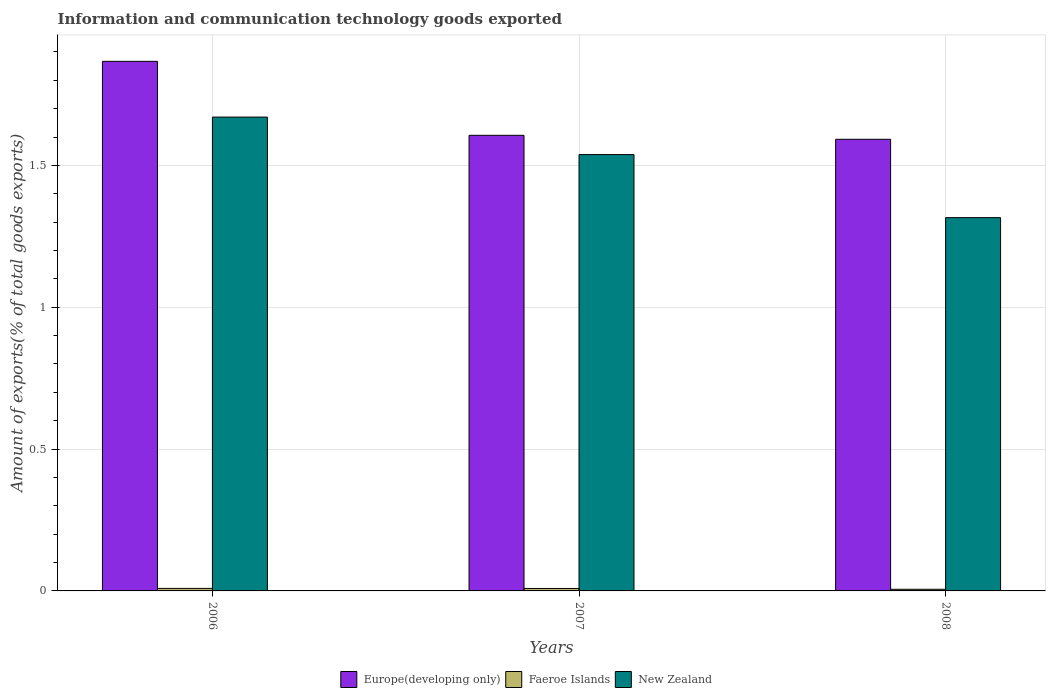How many groups of bars are there?
Your answer should be compact. 3. Are the number of bars per tick equal to the number of legend labels?
Offer a very short reply. Yes. How many bars are there on the 2nd tick from the right?
Give a very brief answer. 3. What is the label of the 2nd group of bars from the left?
Provide a short and direct response. 2007. In how many cases, is the number of bars for a given year not equal to the number of legend labels?
Give a very brief answer. 0. What is the amount of goods exported in Europe(developing only) in 2006?
Provide a short and direct response. 1.87. Across all years, what is the maximum amount of goods exported in New Zealand?
Offer a very short reply. 1.67. Across all years, what is the minimum amount of goods exported in Faeroe Islands?
Provide a succinct answer. 0.01. What is the total amount of goods exported in New Zealand in the graph?
Provide a succinct answer. 4.52. What is the difference between the amount of goods exported in Faeroe Islands in 2006 and that in 2008?
Ensure brevity in your answer.  0. What is the difference between the amount of goods exported in Europe(developing only) in 2007 and the amount of goods exported in New Zealand in 2006?
Offer a very short reply. -0.06. What is the average amount of goods exported in Europe(developing only) per year?
Your answer should be compact. 1.69. In the year 2007, what is the difference between the amount of goods exported in Europe(developing only) and amount of goods exported in Faeroe Islands?
Ensure brevity in your answer.  1.6. What is the ratio of the amount of goods exported in Faeroe Islands in 2006 to that in 2007?
Ensure brevity in your answer.  1.03. What is the difference between the highest and the second highest amount of goods exported in Faeroe Islands?
Make the answer very short. 0. What is the difference between the highest and the lowest amount of goods exported in Faeroe Islands?
Offer a terse response. 0. In how many years, is the amount of goods exported in New Zealand greater than the average amount of goods exported in New Zealand taken over all years?
Make the answer very short. 2. What does the 1st bar from the left in 2008 represents?
Make the answer very short. Europe(developing only). What does the 1st bar from the right in 2007 represents?
Keep it short and to the point. New Zealand. Is it the case that in every year, the sum of the amount of goods exported in Europe(developing only) and amount of goods exported in New Zealand is greater than the amount of goods exported in Faeroe Islands?
Make the answer very short. Yes. Are all the bars in the graph horizontal?
Offer a terse response. No. How many years are there in the graph?
Keep it short and to the point. 3. What is the difference between two consecutive major ticks on the Y-axis?
Keep it short and to the point. 0.5. Are the values on the major ticks of Y-axis written in scientific E-notation?
Provide a short and direct response. No. Does the graph contain any zero values?
Make the answer very short. No. Does the graph contain grids?
Provide a succinct answer. Yes. How many legend labels are there?
Keep it short and to the point. 3. What is the title of the graph?
Provide a short and direct response. Information and communication technology goods exported. Does "Afghanistan" appear as one of the legend labels in the graph?
Your response must be concise. No. What is the label or title of the Y-axis?
Make the answer very short. Amount of exports(% of total goods exports). What is the Amount of exports(% of total goods exports) in Europe(developing only) in 2006?
Provide a succinct answer. 1.87. What is the Amount of exports(% of total goods exports) in Faeroe Islands in 2006?
Provide a short and direct response. 0.01. What is the Amount of exports(% of total goods exports) in New Zealand in 2006?
Keep it short and to the point. 1.67. What is the Amount of exports(% of total goods exports) in Europe(developing only) in 2007?
Provide a succinct answer. 1.61. What is the Amount of exports(% of total goods exports) in Faeroe Islands in 2007?
Your response must be concise. 0.01. What is the Amount of exports(% of total goods exports) of New Zealand in 2007?
Make the answer very short. 1.54. What is the Amount of exports(% of total goods exports) in Europe(developing only) in 2008?
Provide a short and direct response. 1.59. What is the Amount of exports(% of total goods exports) in Faeroe Islands in 2008?
Your answer should be compact. 0.01. What is the Amount of exports(% of total goods exports) in New Zealand in 2008?
Ensure brevity in your answer.  1.32. Across all years, what is the maximum Amount of exports(% of total goods exports) in Europe(developing only)?
Give a very brief answer. 1.87. Across all years, what is the maximum Amount of exports(% of total goods exports) of Faeroe Islands?
Give a very brief answer. 0.01. Across all years, what is the maximum Amount of exports(% of total goods exports) in New Zealand?
Ensure brevity in your answer.  1.67. Across all years, what is the minimum Amount of exports(% of total goods exports) in Europe(developing only)?
Keep it short and to the point. 1.59. Across all years, what is the minimum Amount of exports(% of total goods exports) of Faeroe Islands?
Provide a short and direct response. 0.01. Across all years, what is the minimum Amount of exports(% of total goods exports) of New Zealand?
Give a very brief answer. 1.32. What is the total Amount of exports(% of total goods exports) in Europe(developing only) in the graph?
Ensure brevity in your answer.  5.06. What is the total Amount of exports(% of total goods exports) of Faeroe Islands in the graph?
Your response must be concise. 0.02. What is the total Amount of exports(% of total goods exports) in New Zealand in the graph?
Provide a short and direct response. 4.52. What is the difference between the Amount of exports(% of total goods exports) in Europe(developing only) in 2006 and that in 2007?
Make the answer very short. 0.26. What is the difference between the Amount of exports(% of total goods exports) of Faeroe Islands in 2006 and that in 2007?
Provide a short and direct response. 0. What is the difference between the Amount of exports(% of total goods exports) in New Zealand in 2006 and that in 2007?
Your answer should be very brief. 0.13. What is the difference between the Amount of exports(% of total goods exports) in Europe(developing only) in 2006 and that in 2008?
Make the answer very short. 0.27. What is the difference between the Amount of exports(% of total goods exports) in Faeroe Islands in 2006 and that in 2008?
Your response must be concise. 0. What is the difference between the Amount of exports(% of total goods exports) of New Zealand in 2006 and that in 2008?
Make the answer very short. 0.35. What is the difference between the Amount of exports(% of total goods exports) in Europe(developing only) in 2007 and that in 2008?
Your answer should be very brief. 0.01. What is the difference between the Amount of exports(% of total goods exports) of Faeroe Islands in 2007 and that in 2008?
Your response must be concise. 0. What is the difference between the Amount of exports(% of total goods exports) in New Zealand in 2007 and that in 2008?
Your response must be concise. 0.22. What is the difference between the Amount of exports(% of total goods exports) of Europe(developing only) in 2006 and the Amount of exports(% of total goods exports) of Faeroe Islands in 2007?
Make the answer very short. 1.86. What is the difference between the Amount of exports(% of total goods exports) of Europe(developing only) in 2006 and the Amount of exports(% of total goods exports) of New Zealand in 2007?
Ensure brevity in your answer.  0.33. What is the difference between the Amount of exports(% of total goods exports) of Faeroe Islands in 2006 and the Amount of exports(% of total goods exports) of New Zealand in 2007?
Offer a terse response. -1.53. What is the difference between the Amount of exports(% of total goods exports) of Europe(developing only) in 2006 and the Amount of exports(% of total goods exports) of Faeroe Islands in 2008?
Ensure brevity in your answer.  1.86. What is the difference between the Amount of exports(% of total goods exports) of Europe(developing only) in 2006 and the Amount of exports(% of total goods exports) of New Zealand in 2008?
Offer a terse response. 0.55. What is the difference between the Amount of exports(% of total goods exports) in Faeroe Islands in 2006 and the Amount of exports(% of total goods exports) in New Zealand in 2008?
Offer a terse response. -1.31. What is the difference between the Amount of exports(% of total goods exports) in Europe(developing only) in 2007 and the Amount of exports(% of total goods exports) in Faeroe Islands in 2008?
Make the answer very short. 1.6. What is the difference between the Amount of exports(% of total goods exports) in Europe(developing only) in 2007 and the Amount of exports(% of total goods exports) in New Zealand in 2008?
Keep it short and to the point. 0.29. What is the difference between the Amount of exports(% of total goods exports) in Faeroe Islands in 2007 and the Amount of exports(% of total goods exports) in New Zealand in 2008?
Make the answer very short. -1.31. What is the average Amount of exports(% of total goods exports) in Europe(developing only) per year?
Provide a succinct answer. 1.69. What is the average Amount of exports(% of total goods exports) in Faeroe Islands per year?
Keep it short and to the point. 0.01. What is the average Amount of exports(% of total goods exports) of New Zealand per year?
Your response must be concise. 1.51. In the year 2006, what is the difference between the Amount of exports(% of total goods exports) of Europe(developing only) and Amount of exports(% of total goods exports) of Faeroe Islands?
Your answer should be compact. 1.86. In the year 2006, what is the difference between the Amount of exports(% of total goods exports) in Europe(developing only) and Amount of exports(% of total goods exports) in New Zealand?
Provide a short and direct response. 0.2. In the year 2006, what is the difference between the Amount of exports(% of total goods exports) of Faeroe Islands and Amount of exports(% of total goods exports) of New Zealand?
Ensure brevity in your answer.  -1.66. In the year 2007, what is the difference between the Amount of exports(% of total goods exports) of Europe(developing only) and Amount of exports(% of total goods exports) of Faeroe Islands?
Give a very brief answer. 1.6. In the year 2007, what is the difference between the Amount of exports(% of total goods exports) in Europe(developing only) and Amount of exports(% of total goods exports) in New Zealand?
Provide a short and direct response. 0.07. In the year 2007, what is the difference between the Amount of exports(% of total goods exports) in Faeroe Islands and Amount of exports(% of total goods exports) in New Zealand?
Your answer should be compact. -1.53. In the year 2008, what is the difference between the Amount of exports(% of total goods exports) of Europe(developing only) and Amount of exports(% of total goods exports) of Faeroe Islands?
Make the answer very short. 1.59. In the year 2008, what is the difference between the Amount of exports(% of total goods exports) in Europe(developing only) and Amount of exports(% of total goods exports) in New Zealand?
Ensure brevity in your answer.  0.28. In the year 2008, what is the difference between the Amount of exports(% of total goods exports) of Faeroe Islands and Amount of exports(% of total goods exports) of New Zealand?
Give a very brief answer. -1.31. What is the ratio of the Amount of exports(% of total goods exports) of Europe(developing only) in 2006 to that in 2007?
Offer a terse response. 1.16. What is the ratio of the Amount of exports(% of total goods exports) of Faeroe Islands in 2006 to that in 2007?
Provide a short and direct response. 1.03. What is the ratio of the Amount of exports(% of total goods exports) of New Zealand in 2006 to that in 2007?
Your answer should be compact. 1.09. What is the ratio of the Amount of exports(% of total goods exports) of Europe(developing only) in 2006 to that in 2008?
Provide a short and direct response. 1.17. What is the ratio of the Amount of exports(% of total goods exports) in Faeroe Islands in 2006 to that in 2008?
Offer a very short reply. 1.53. What is the ratio of the Amount of exports(% of total goods exports) in New Zealand in 2006 to that in 2008?
Keep it short and to the point. 1.27. What is the ratio of the Amount of exports(% of total goods exports) in Europe(developing only) in 2007 to that in 2008?
Offer a terse response. 1.01. What is the ratio of the Amount of exports(% of total goods exports) of Faeroe Islands in 2007 to that in 2008?
Keep it short and to the point. 1.49. What is the ratio of the Amount of exports(% of total goods exports) of New Zealand in 2007 to that in 2008?
Your answer should be compact. 1.17. What is the difference between the highest and the second highest Amount of exports(% of total goods exports) of Europe(developing only)?
Your answer should be compact. 0.26. What is the difference between the highest and the second highest Amount of exports(% of total goods exports) in Faeroe Islands?
Offer a very short reply. 0. What is the difference between the highest and the second highest Amount of exports(% of total goods exports) in New Zealand?
Give a very brief answer. 0.13. What is the difference between the highest and the lowest Amount of exports(% of total goods exports) of Europe(developing only)?
Your answer should be very brief. 0.27. What is the difference between the highest and the lowest Amount of exports(% of total goods exports) in Faeroe Islands?
Keep it short and to the point. 0. What is the difference between the highest and the lowest Amount of exports(% of total goods exports) in New Zealand?
Provide a short and direct response. 0.35. 